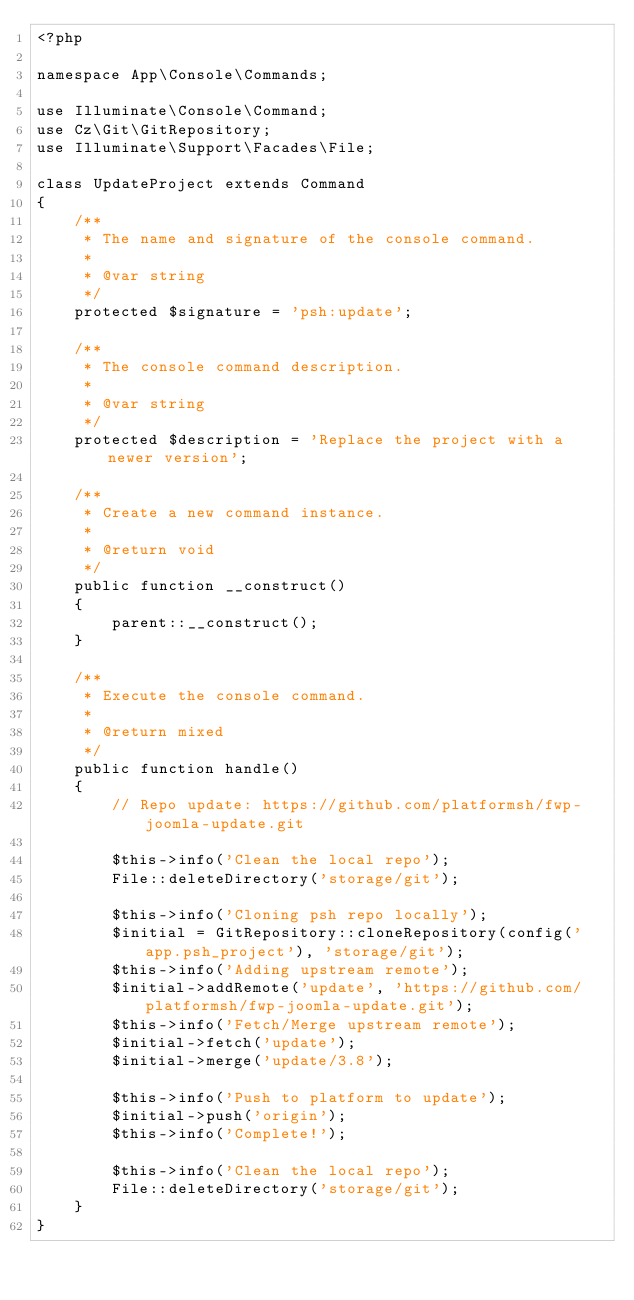Convert code to text. <code><loc_0><loc_0><loc_500><loc_500><_PHP_><?php

namespace App\Console\Commands;

use Illuminate\Console\Command;
use Cz\Git\GitRepository;
use Illuminate\Support\Facades\File;

class UpdateProject extends Command
{
    /**
     * The name and signature of the console command.
     *
     * @var string
     */
    protected $signature = 'psh:update';

    /**
     * The console command description.
     *
     * @var string
     */
    protected $description = 'Replace the project with a newer version';

    /**
     * Create a new command instance.
     *
     * @return void
     */
    public function __construct()
    {
        parent::__construct();
    }

    /**
     * Execute the console command.
     *
     * @return mixed
     */
    public function handle()
    {
        // Repo update: https://github.com/platformsh/fwp-joomla-update.git

        $this->info('Clean the local repo');
        File::deleteDirectory('storage/git');

        $this->info('Cloning psh repo locally');
        $initial = GitRepository::cloneRepository(config('app.psh_project'), 'storage/git');
        $this->info('Adding upstream remote');
        $initial->addRemote('update', 'https://github.com/platformsh/fwp-joomla-update.git');
        $this->info('Fetch/Merge upstream remote');
        $initial->fetch('update');
        $initial->merge('update/3.8');
        
        $this->info('Push to platform to update');
        $initial->push('origin');
        $this->info('Complete!');

        $this->info('Clean the local repo');
        File::deleteDirectory('storage/git');
    }
}</code> 